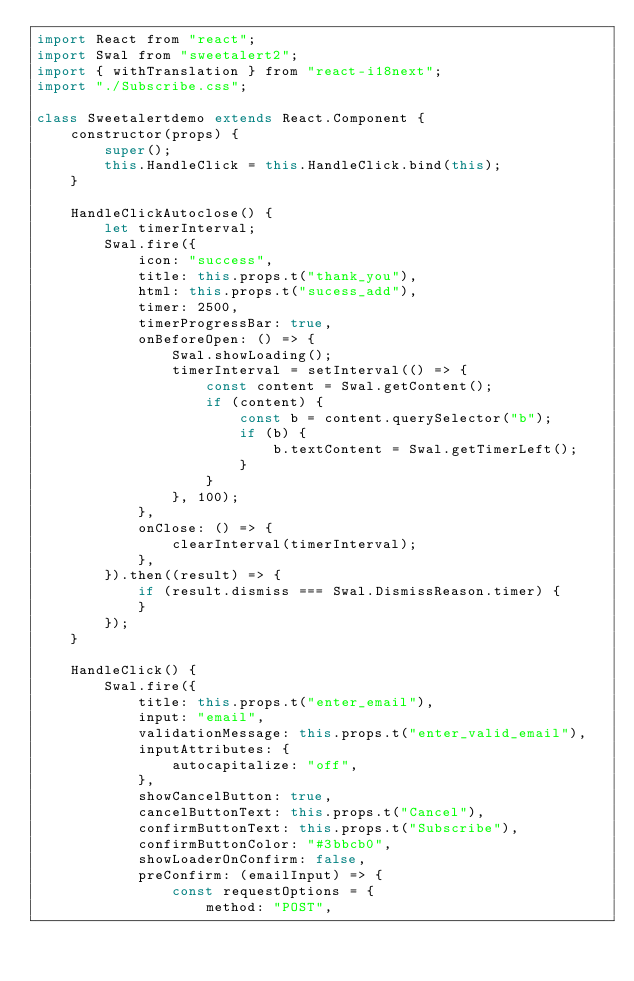<code> <loc_0><loc_0><loc_500><loc_500><_JavaScript_>import React from "react";
import Swal from "sweetalert2";
import { withTranslation } from "react-i18next";
import "./Subscribe.css";

class Sweetalertdemo extends React.Component {
    constructor(props) {
        super();
        this.HandleClick = this.HandleClick.bind(this);
    }

    HandleClickAutoclose() {
        let timerInterval;
        Swal.fire({
            icon: "success",
            title: this.props.t("thank_you"),
            html: this.props.t("sucess_add"),
            timer: 2500,
            timerProgressBar: true,
            onBeforeOpen: () => {
                Swal.showLoading();
                timerInterval = setInterval(() => {
                    const content = Swal.getContent();
                    if (content) {
                        const b = content.querySelector("b");
                        if (b) {
                            b.textContent = Swal.getTimerLeft();
                        }
                    }
                }, 100);
            },
            onClose: () => {
                clearInterval(timerInterval);
            },
        }).then((result) => {
            if (result.dismiss === Swal.DismissReason.timer) {
            }
        });
    }

    HandleClick() {
        Swal.fire({
            title: this.props.t("enter_email"),
            input: "email",
            validationMessage: this.props.t("enter_valid_email"),
            inputAttributes: {
                autocapitalize: "off",
            },
            showCancelButton: true,
            cancelButtonText: this.props.t("Cancel"),
            confirmButtonText: this.props.t("Subscribe"),
            confirmButtonColor: "#3bbcb0",
            showLoaderOnConfirm: false,
            preConfirm: (emailInput) => {
                const requestOptions = {
                    method: "POST",</code> 